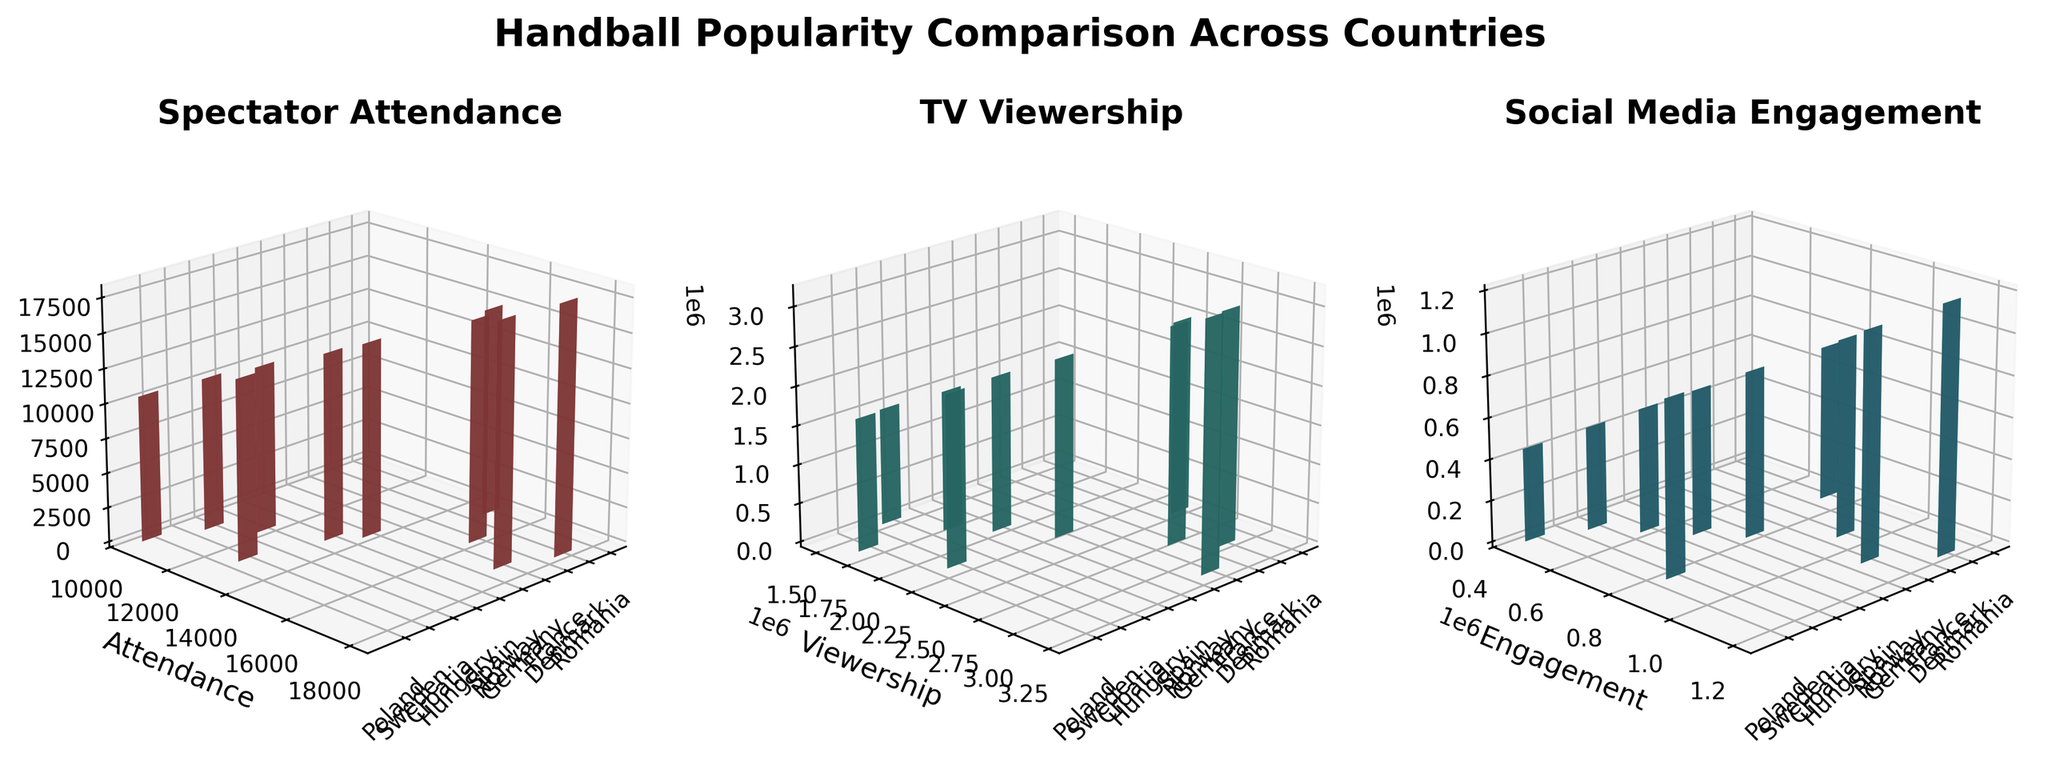What's the title of the figure? The title is usually found at the top of the figure. It is a brief description of what the figure represents.
Answer: Handball Popularity Comparison Across Countries Which country has the highest spectator attendance? Look at the heights of the bars in the 'Spectator Attendance' subplot and identify the highest.
Answer: Denmark What is the social media engagement for France? Look at the 'Social Media Engagement' subplot and find the height of the bar labeled 'France'.
Answer: 950000 Which metric has the highest value for Germany? Compare the heights of the bars representing Germany across the three subplots to determine which one is the tallest.
Answer: TV Viewership Which country has the lowest TV viewership, and what is the value? Look at the smallest bar in the 'TV Viewership' subplot and read the value associated with it.
Answer: Croatia, 1500000 How many data points are in each subplot? Count the number of bars in any of the subplots. Since each subplot represents all countries, the number of bars is the same across all subplots.
Answer: 10 What is the difference in social media engagement between Denmark and Poland? Locate the bars for Denmark and Poland in the 'Social Media Engagement' subplot, note their heights, and subtract the value for Poland from Denmark.
Answer: 750000 Which country has a higher TV viewership, Norway or Spain? Compare the heights of the bars for Norway and Spain in the 'TV Viewership' subplot.
Answer: Norway Which country has the second-highest spectator attendance? Identify the country with the highest bar in the 'Spectator Attendance' subplot and then find the next tallest bar.
Answer: Germany How does the spectator attendance in Romania compare to that in Hungary? Compare the heights of the bars representing spectator attendance for Romania and Hungary.
Answer: Romania has higher spectator attendance than Hungary 